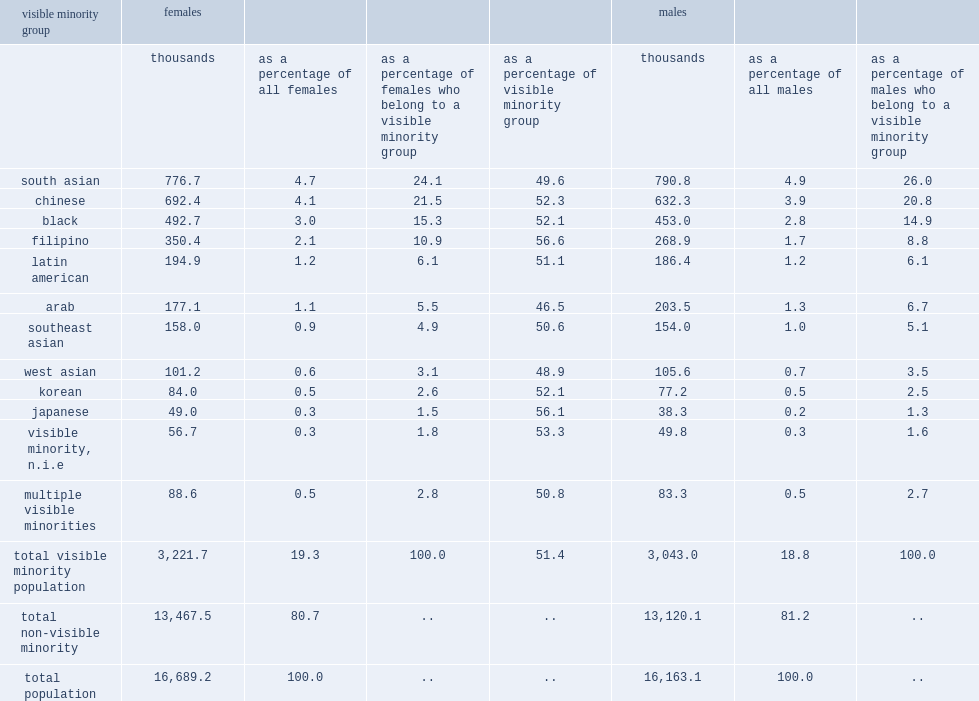In 2011, how many women and girls in canada who belonged to a visible minority group? 3221.7. In 2011, what the percentage did women and girls in canada who belonged to a visible minority group account for? 19.3. What were the three largest groups among females who reported a visible minority status in 2011? South asian chinese black. 